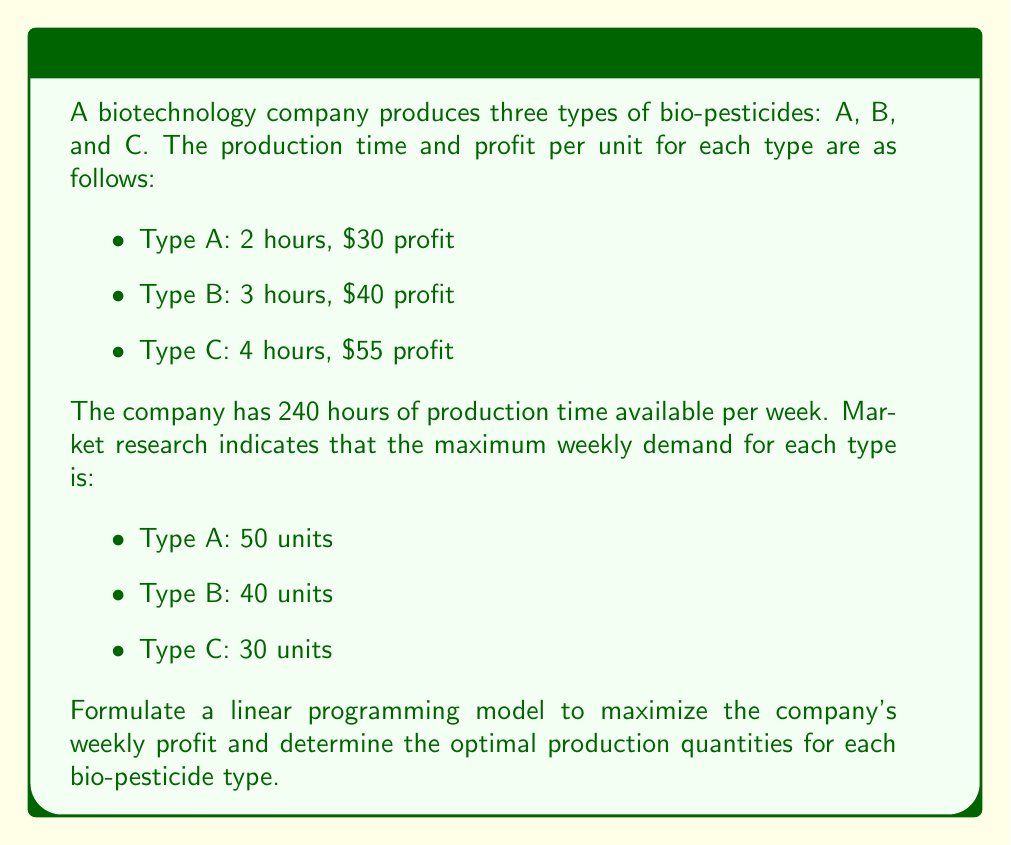Give your solution to this math problem. To solve this optimization problem, we'll use linear programming. Let's follow these steps:

1. Define variables:
   Let $x_1$, $x_2$, and $x_3$ represent the number of units produced for types A, B, and C, respectively.

2. Formulate the objective function:
   Maximize profit: $Z = 30x_1 + 40x_2 + 55x_3$

3. Identify constraints:
   a) Production time constraint:
      $2x_1 + 3x_2 + 4x_3 \leq 240$
   
   b) Maximum demand constraints:
      $x_1 \leq 50$
      $x_2 \leq 40$
      $x_3 \leq 30$
   
   c) Non-negativity constraints:
      $x_1, x_2, x_3 \geq 0$

4. Solve using the simplex method or linear programming software:
   The optimal solution is:
   $x_1 = 50$, $x_2 = 40$, $x_3 = 15$

5. Calculate the maximum profit:
   $Z = 30(50) + 40(40) + 55(15) = 1,500 + 1,600 + 825 = 3,925$

Therefore, the company should produce 50 units of Type A, 40 units of Type B, and 15 units of Type C bio-pesticides to maximize their weekly profit at $3,925.
Answer: The optimal production quantities are:
Type A: 50 units
Type B: 40 units
Type C: 15 units
Maximum weekly profit: $3,925 